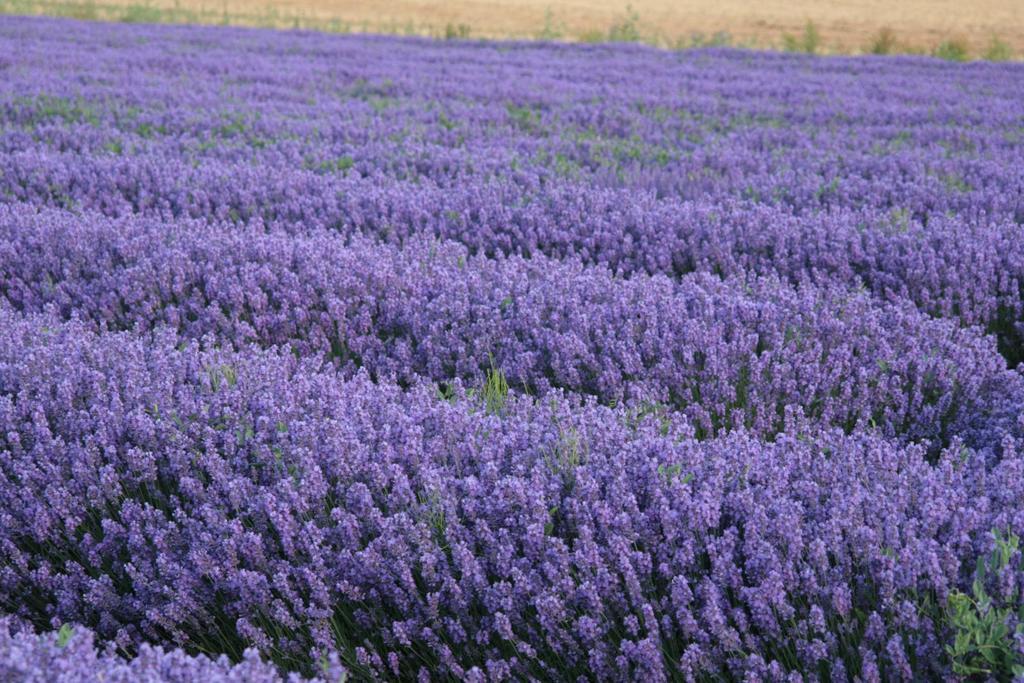Describe this image in one or two sentences. In this image we can see a group of plants and flowers. At the top we can see the ground. 